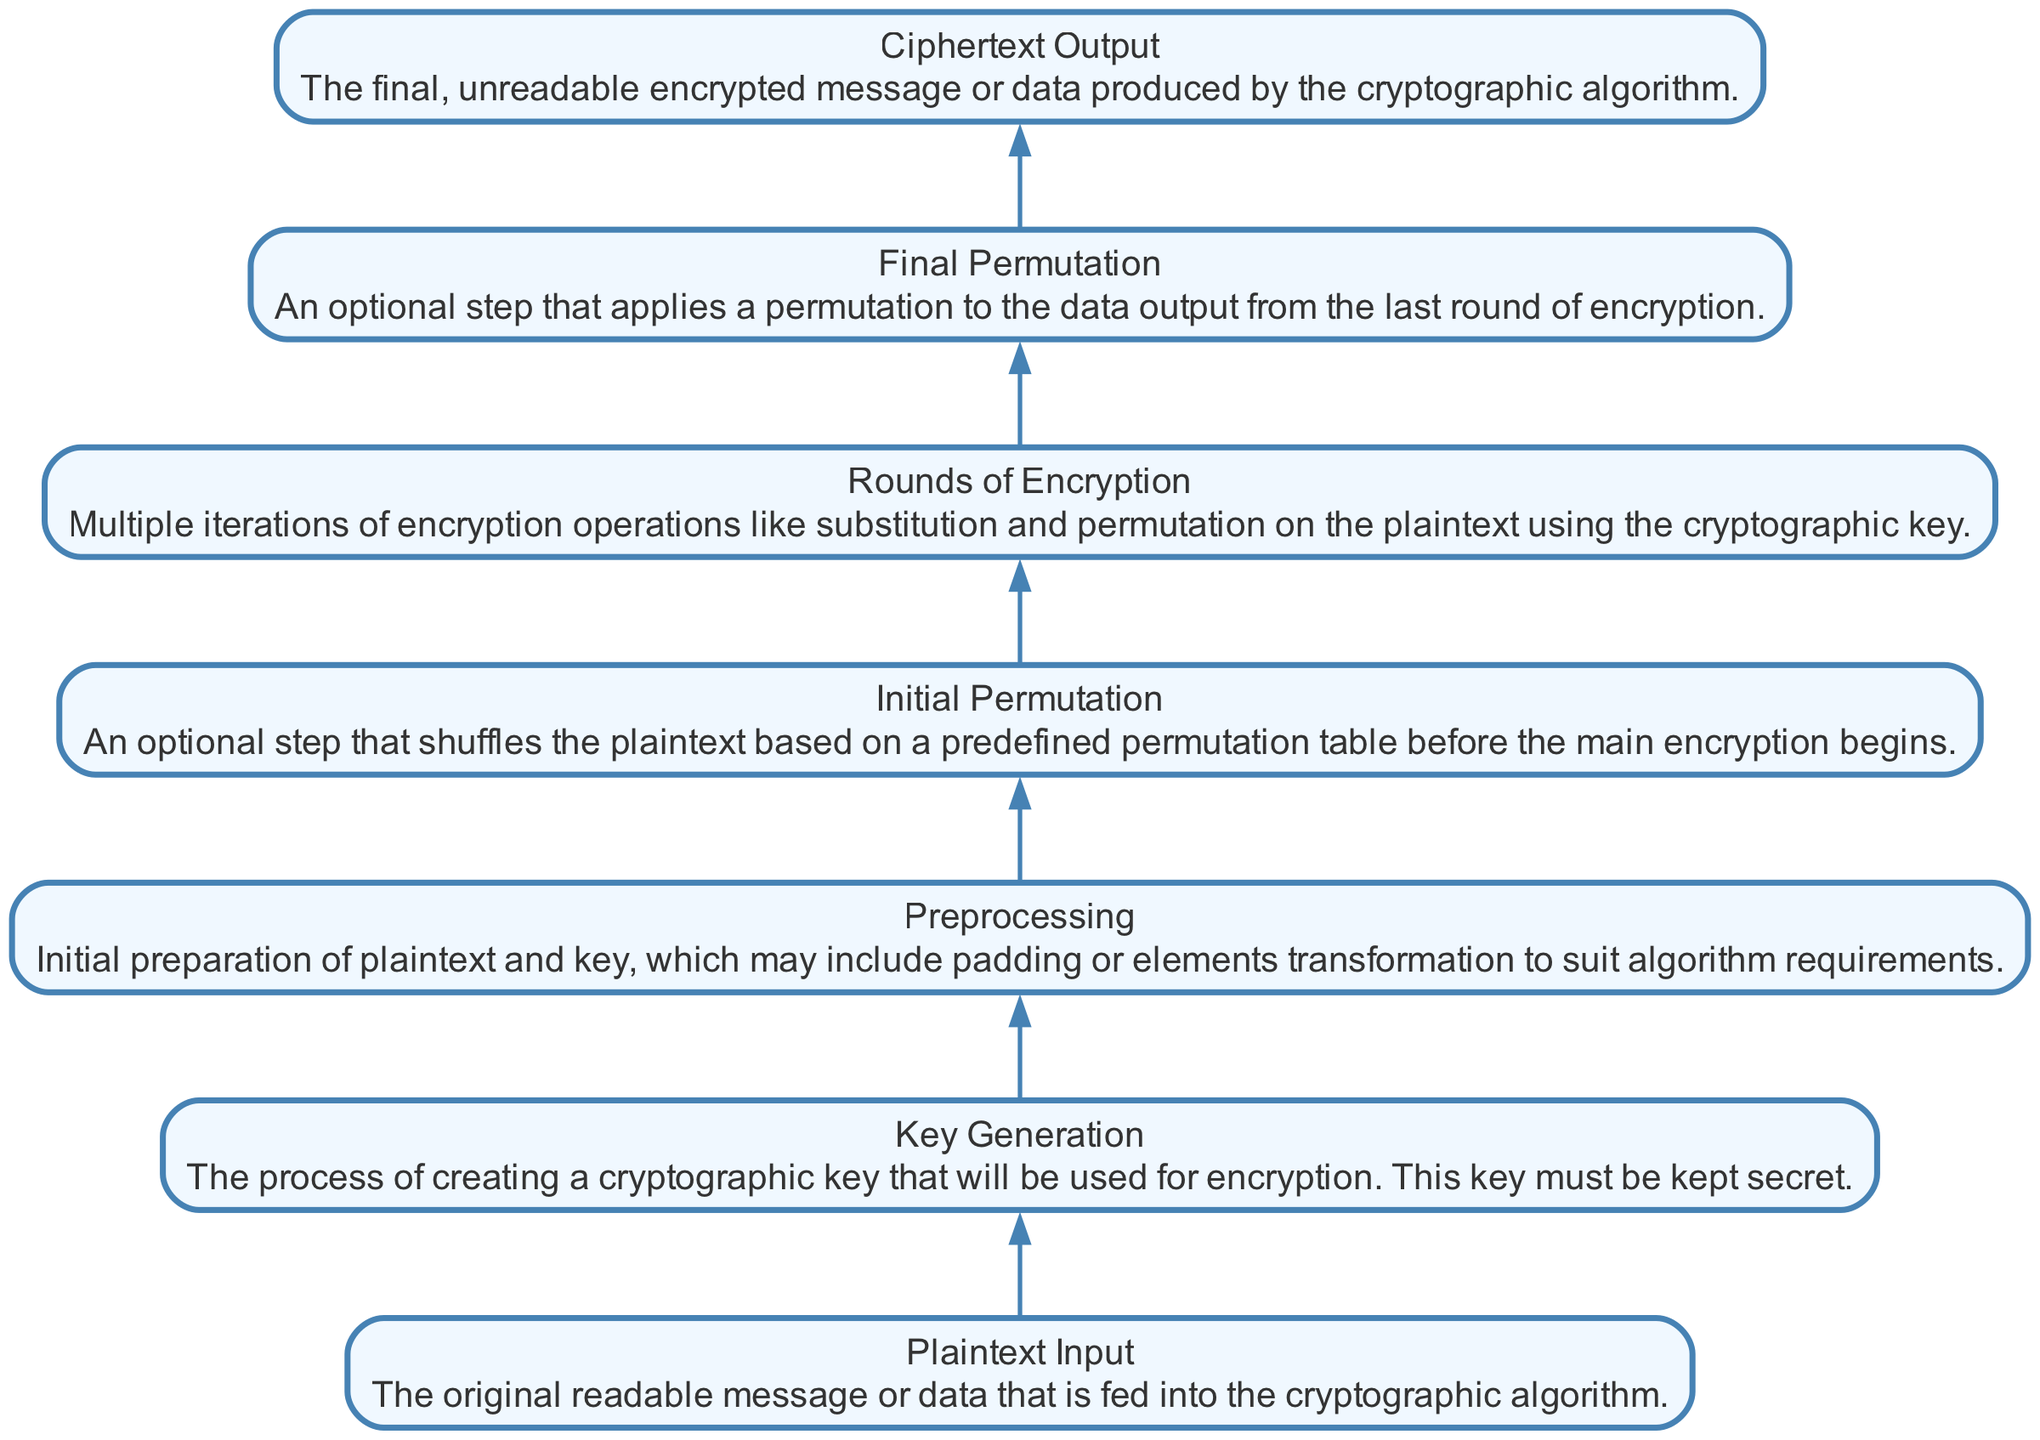What is the topmost element in the flow chart? The topmost element in the flow chart represents the final output of the cryptographic algorithm, which is the ciphertext output. It is positioned at the top of the diagram.
Answer: Ciphertext Output How many nodes are present in the diagram? The nodes represent different stages of the cryptographic process, and when counting all the nodes from plaintext input to ciphertext output, there are 7 nodes in total.
Answer: 7 What is the function of the “Rounds of Encryption” node? The "Rounds of Encryption" node signifies multiple iterations of encryption processes applied to the plaintext using the cryptographic key. It follows the initial permutation node in the flow chart.
Answer: Multiple iterations of encryption operations What comes immediately before the “Final Permutation”? In the flow of the diagram, the "Final Permutation" node follows directly after the "Rounds of Encryption" node, indicating that final adjustments to the output are made after all rounds of encryption have been completed.
Answer: Rounds of Encryption Which element is responsible for preparing the plaintext and key for encryption? The "Preprocessing" element is designated for the initial preparation of the plaintext and key. It involves adjustments like padding to ensure they meet the algorithm's requirements before further processing occurs.
Answer: Preprocessing What is the purpose of the "Key Generation" stage? The "Key Generation" stage is crucial for creating a cryptographic key that is essential for the encryption process. This key must remain a secret to maintain the security of the cipher, as indicated by its placement in the diagram before the encryption steps.
Answer: Creating a cryptographic key How many operations are performed after the “Initial Permutation”? After the "Initial Permutation," there are a series of operations defined as the "Rounds of Encryption," which encompass multiple iterations of specific encryption tasks. This indicates that several operations are performed at this stage, though the exact number of rounds could vary based on the specific cryptographic algorithm.
Answer: Multiple iterations of encryption operations What element is first in the flow of the cryptographic algorithm? The first element in the flow of the cryptographic algorithm is the "Plaintext Input," which represents the original readable message that is to be encrypted before any further processing occurs.
Answer: Plaintext Input 